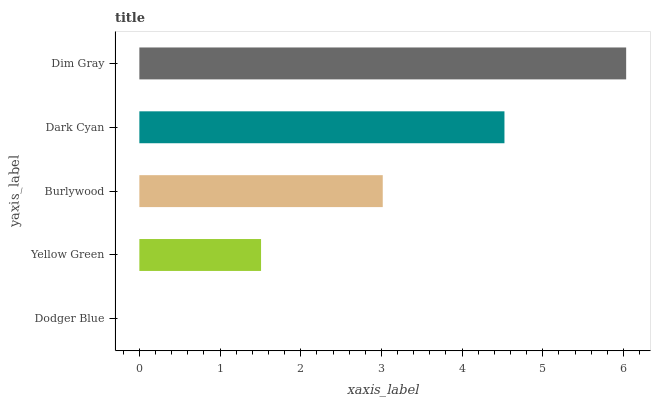Is Dodger Blue the minimum?
Answer yes or no. Yes. Is Dim Gray the maximum?
Answer yes or no. Yes. Is Yellow Green the minimum?
Answer yes or no. No. Is Yellow Green the maximum?
Answer yes or no. No. Is Yellow Green greater than Dodger Blue?
Answer yes or no. Yes. Is Dodger Blue less than Yellow Green?
Answer yes or no. Yes. Is Dodger Blue greater than Yellow Green?
Answer yes or no. No. Is Yellow Green less than Dodger Blue?
Answer yes or no. No. Is Burlywood the high median?
Answer yes or no. Yes. Is Burlywood the low median?
Answer yes or no. Yes. Is Dim Gray the high median?
Answer yes or no. No. Is Dark Cyan the low median?
Answer yes or no. No. 